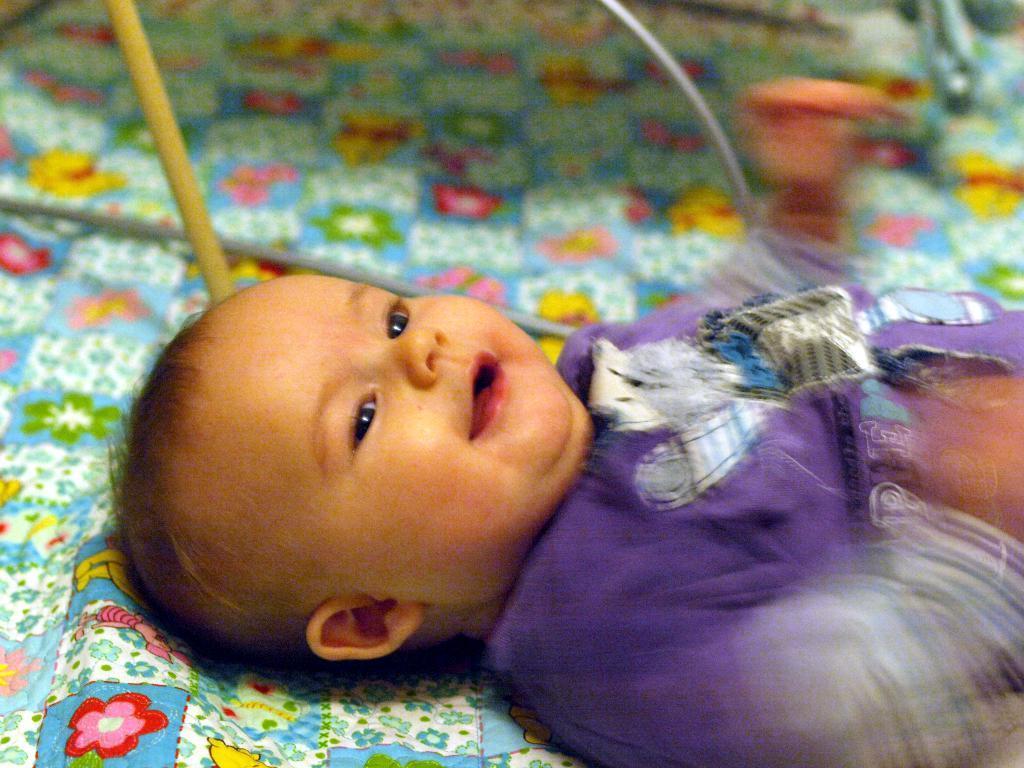How would you summarize this image in a sentence or two? In this picture we can see a small baby wearing purple dress, smiling and lying on the bed. 